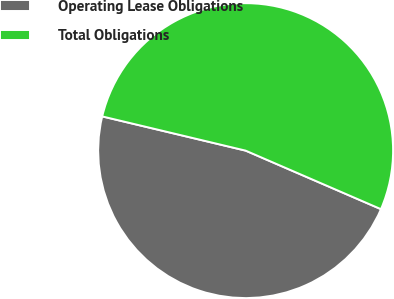Convert chart to OTSL. <chart><loc_0><loc_0><loc_500><loc_500><pie_chart><fcel>Operating Lease Obligations<fcel>Total Obligations<nl><fcel>47.23%<fcel>52.77%<nl></chart> 